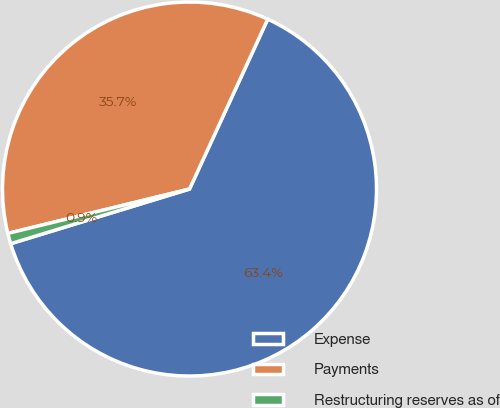Convert chart. <chart><loc_0><loc_0><loc_500><loc_500><pie_chart><fcel>Expense<fcel>Payments<fcel>Restructuring reserves as of<nl><fcel>63.41%<fcel>35.68%<fcel>0.91%<nl></chart> 